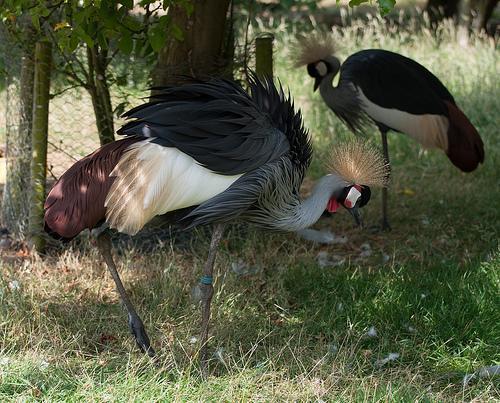How many birds are there?
Give a very brief answer. 2. How many bands are on the bird's leg?
Give a very brief answer. 1. How many legs does the foreground bird have?
Give a very brief answer. 2. 